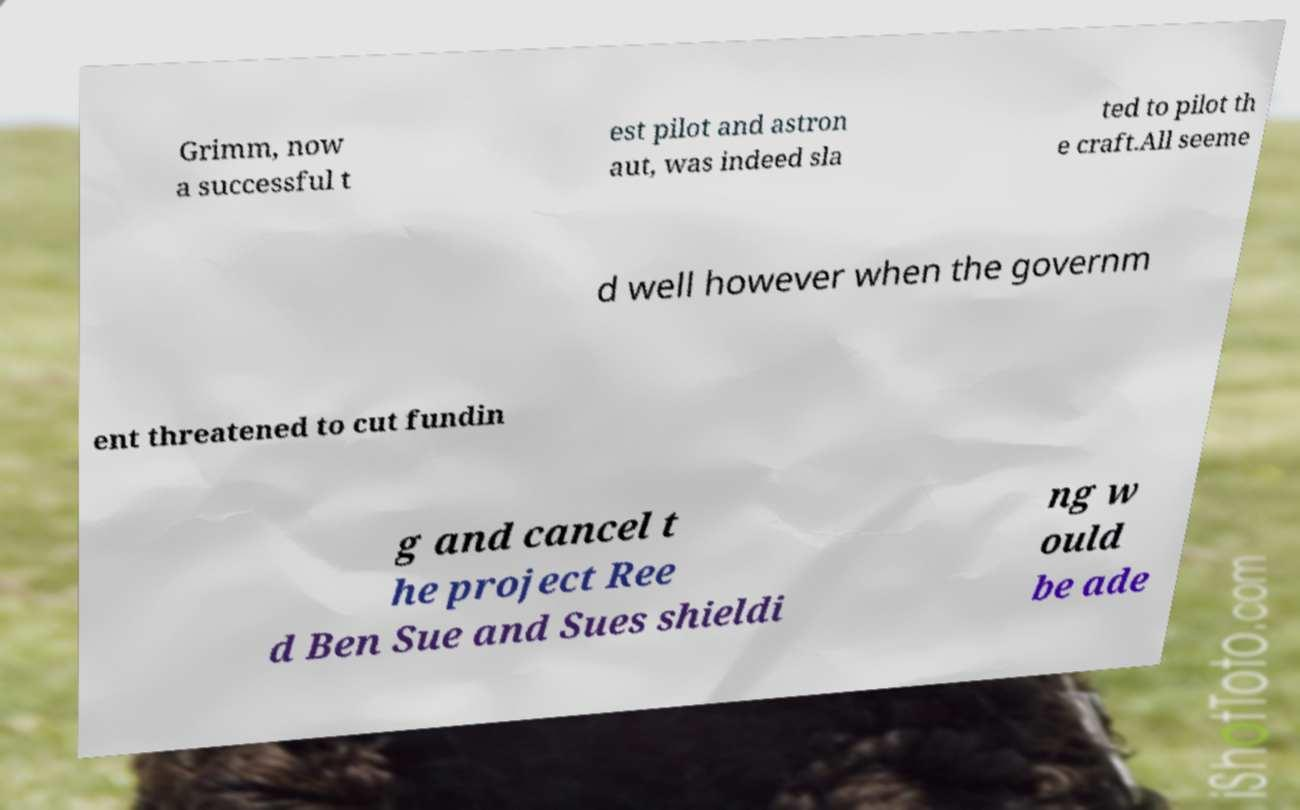Can you read and provide the text displayed in the image?This photo seems to have some interesting text. Can you extract and type it out for me? Grimm, now a successful t est pilot and astron aut, was indeed sla ted to pilot th e craft.All seeme d well however when the governm ent threatened to cut fundin g and cancel t he project Ree d Ben Sue and Sues shieldi ng w ould be ade 